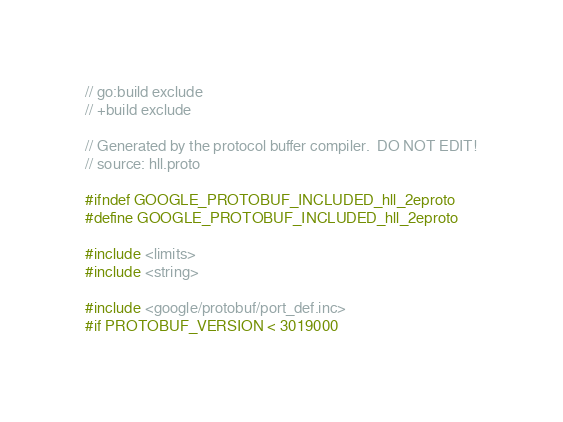<code> <loc_0><loc_0><loc_500><loc_500><_C_>// go:build exclude
// +build exclude

// Generated by the protocol buffer compiler.  DO NOT EDIT!
// source: hll.proto

#ifndef GOOGLE_PROTOBUF_INCLUDED_hll_2eproto
#define GOOGLE_PROTOBUF_INCLUDED_hll_2eproto

#include <limits>
#include <string>

#include <google/protobuf/port_def.inc>
#if PROTOBUF_VERSION < 3019000</code> 